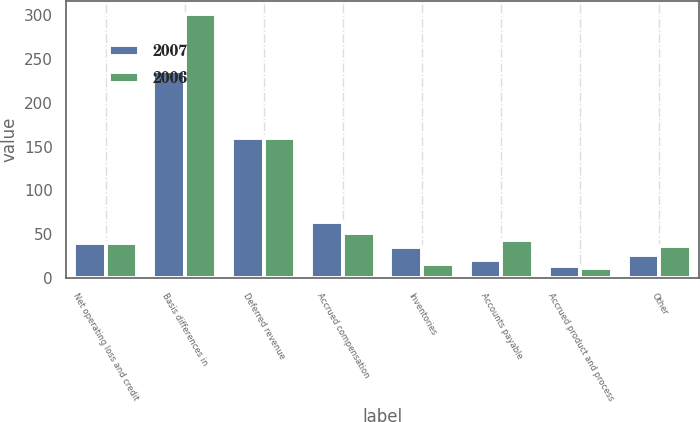Convert chart. <chart><loc_0><loc_0><loc_500><loc_500><stacked_bar_chart><ecel><fcel>Net operating loss and credit<fcel>Basis differences in<fcel>Deferred revenue<fcel>Accrued compensation<fcel>Inventories<fcel>Accounts payable<fcel>Accrued product and process<fcel>Other<nl><fcel>2007<fcel>39.5<fcel>236<fcel>160<fcel>64<fcel>35<fcel>21<fcel>14<fcel>26<nl><fcel>2006<fcel>39.5<fcel>301<fcel>160<fcel>51<fcel>16<fcel>43<fcel>11<fcel>36<nl></chart> 